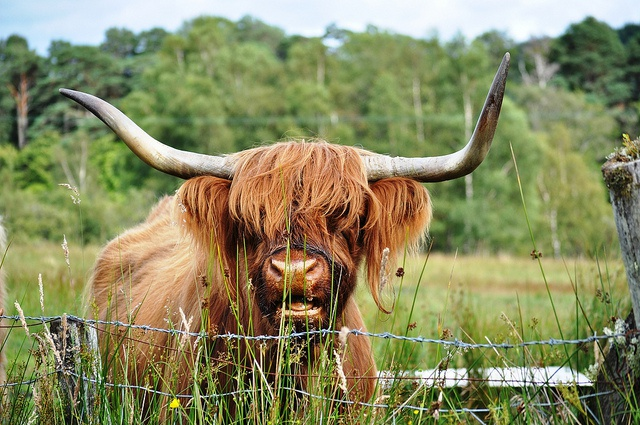Describe the objects in this image and their specific colors. I can see a cow in lightblue, brown, black, maroon, and tan tones in this image. 